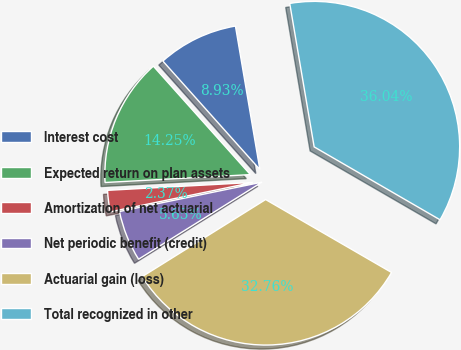Convert chart. <chart><loc_0><loc_0><loc_500><loc_500><pie_chart><fcel>Interest cost<fcel>Expected return on plan assets<fcel>Amortization of net actuarial<fcel>Net periodic benefit (credit)<fcel>Actuarial gain (loss)<fcel>Total recognized in other<nl><fcel>8.93%<fcel>14.25%<fcel>2.37%<fcel>5.65%<fcel>32.76%<fcel>36.04%<nl></chart> 